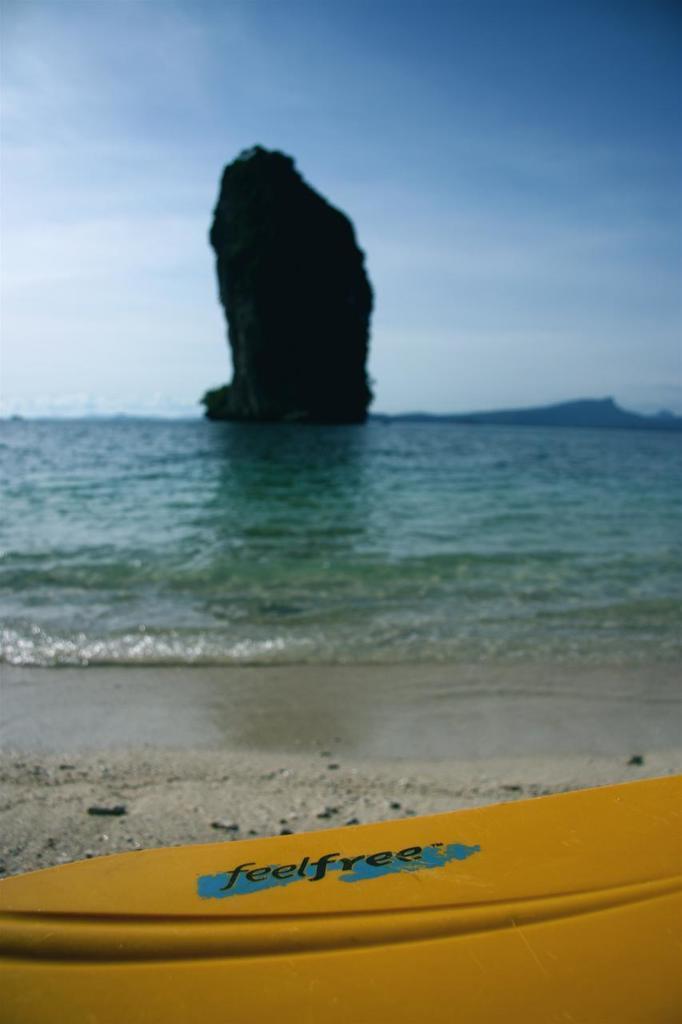Could you give a brief overview of what you see in this image? In this image, we can see some water. We can also see a rock mountain. We can see the sky and some hills. We can also see the ground. We can also see a yellow colored object with some text. 